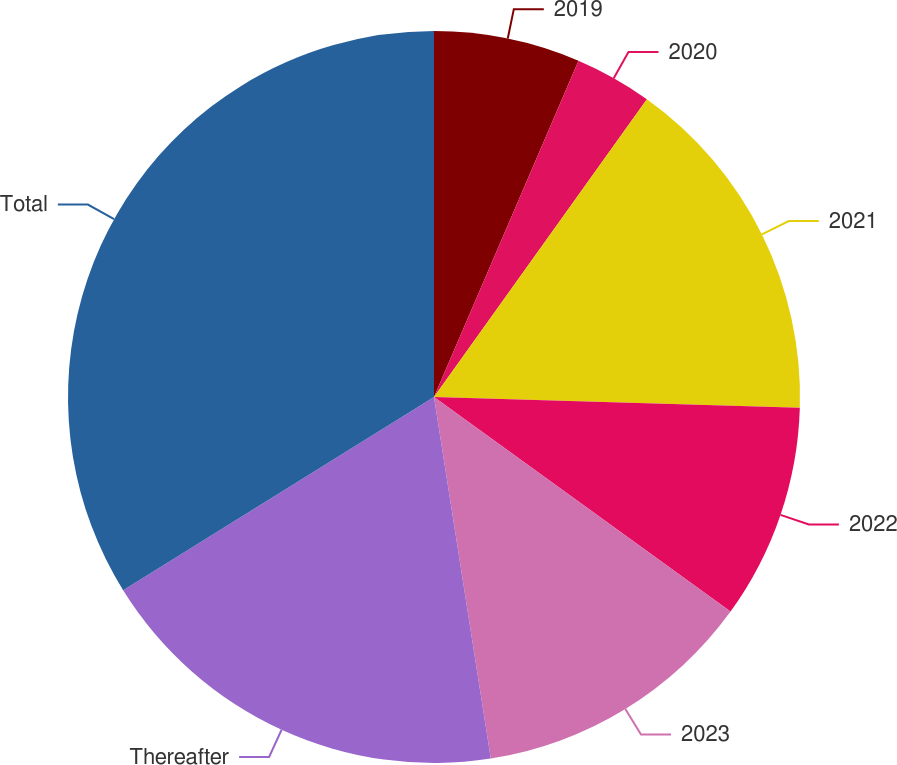Convert chart. <chart><loc_0><loc_0><loc_500><loc_500><pie_chart><fcel>2019<fcel>2020<fcel>2021<fcel>2022<fcel>2023<fcel>Thereafter<fcel>Total<nl><fcel>6.46%<fcel>3.42%<fcel>15.59%<fcel>9.5%<fcel>12.55%<fcel>18.63%<fcel>33.85%<nl></chart> 